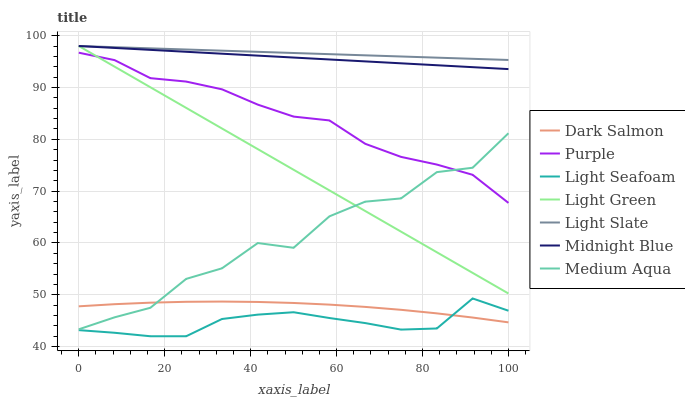Does Light Seafoam have the minimum area under the curve?
Answer yes or no. Yes. Does Light Slate have the maximum area under the curve?
Answer yes or no. Yes. Does Purple have the minimum area under the curve?
Answer yes or no. No. Does Purple have the maximum area under the curve?
Answer yes or no. No. Is Light Green the smoothest?
Answer yes or no. Yes. Is Medium Aqua the roughest?
Answer yes or no. Yes. Is Purple the smoothest?
Answer yes or no. No. Is Purple the roughest?
Answer yes or no. No. Does Light Seafoam have the lowest value?
Answer yes or no. Yes. Does Purple have the lowest value?
Answer yes or no. No. Does Light Green have the highest value?
Answer yes or no. Yes. Does Purple have the highest value?
Answer yes or no. No. Is Light Seafoam less than Purple?
Answer yes or no. Yes. Is Light Slate greater than Purple?
Answer yes or no. Yes. Does Dark Salmon intersect Medium Aqua?
Answer yes or no. Yes. Is Dark Salmon less than Medium Aqua?
Answer yes or no. No. Is Dark Salmon greater than Medium Aqua?
Answer yes or no. No. Does Light Seafoam intersect Purple?
Answer yes or no. No. 